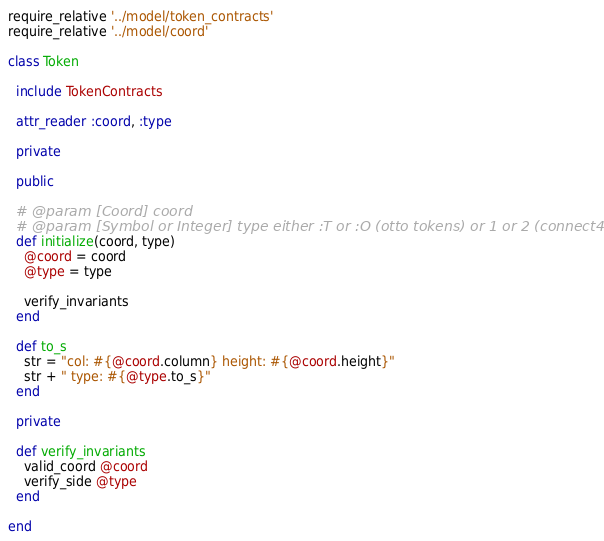Convert code to text. <code><loc_0><loc_0><loc_500><loc_500><_Ruby_>require_relative '../model/token_contracts'
require_relative '../model/coord'

class Token

  include TokenContracts

  attr_reader :coord, :type

  private

  public

  # @param [Coord] coord
  # @param [Symbol or Integer] type either :T or :O (otto tokens) or 1 or 2 (connect4 tokens)
  def initialize(coord, type)
    @coord = coord
    @type = type

    verify_invariants
  end

  def to_s
    str = "col: #{@coord.column} height: #{@coord.height}"
    str + " type: #{@type.to_s}"
  end

  private

  def verify_invariants
    valid_coord @coord
    verify_side @type
  end

end</code> 